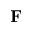<formula> <loc_0><loc_0><loc_500><loc_500>{ F }</formula> 